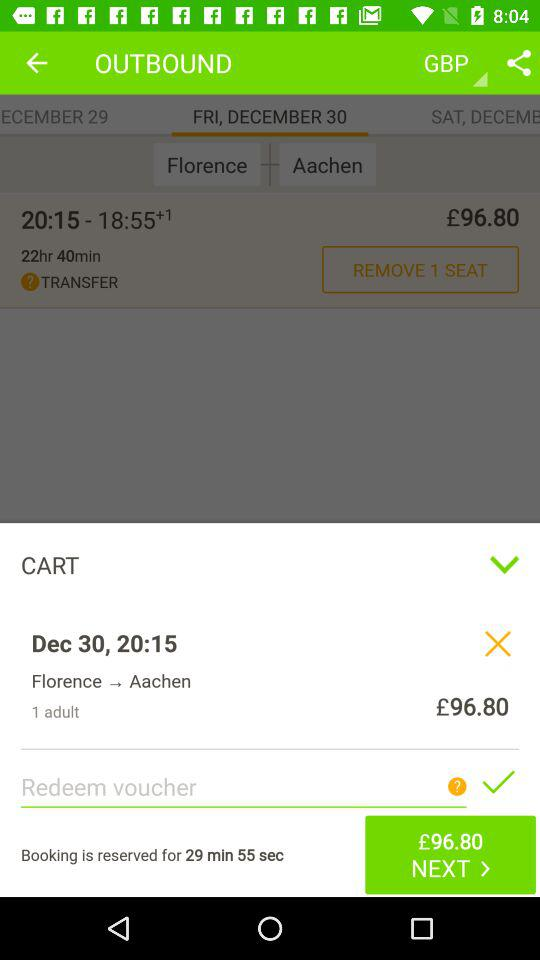What is the time given? The time is 20:15. 